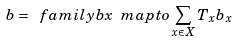<formula> <loc_0><loc_0><loc_500><loc_500>b = \ f a m i l y { b } { x } \ m a p t o \sum _ { x \in X } T _ { x } b _ { x }</formula> 